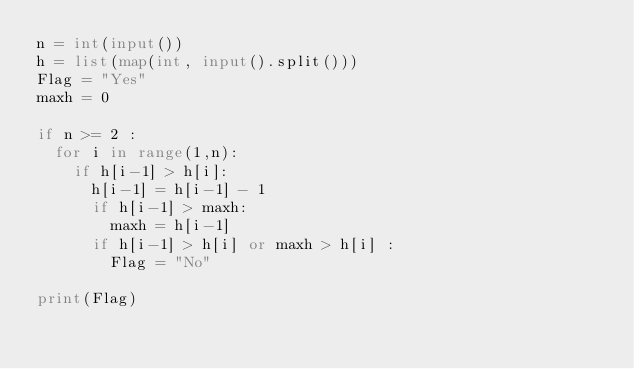Convert code to text. <code><loc_0><loc_0><loc_500><loc_500><_Python_>n = int(input())
h = list(map(int, input().split()))
Flag = "Yes"
maxh = 0

if n >= 2 :
  for i in range(1,n):
    if h[i-1] > h[i]:
      h[i-1] = h[i-1] - 1
      if h[i-1] > maxh:
        maxh = h[i-1] 
      if h[i-1] > h[i] or maxh > h[i] :
        Flag = "No"
      
print(Flag)</code> 